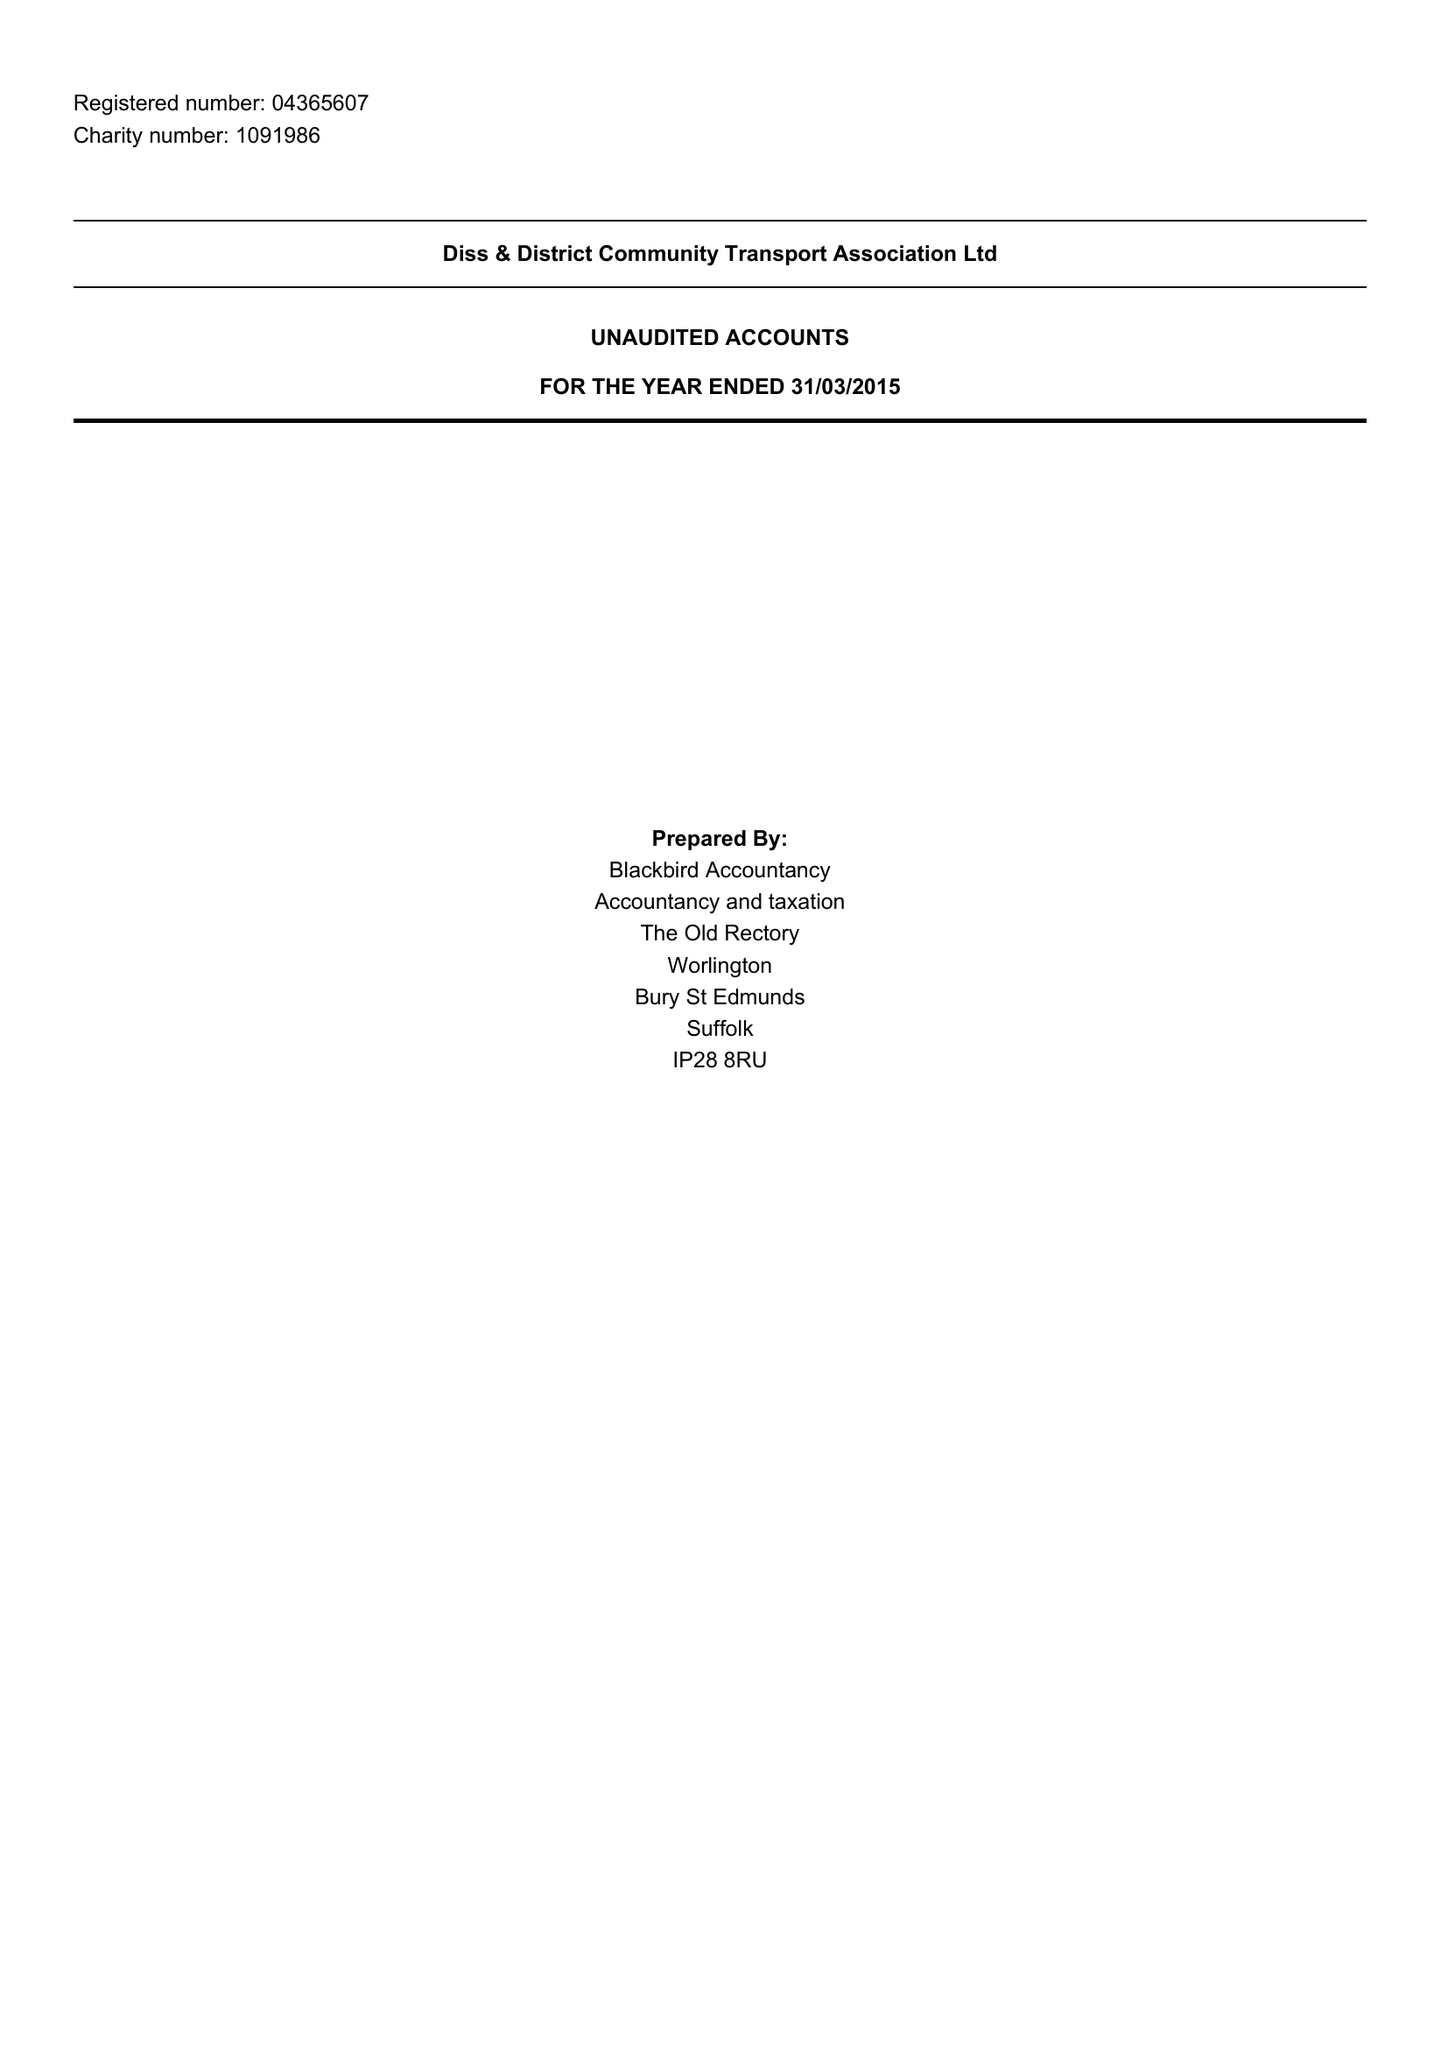What is the value for the charity_number?
Answer the question using a single word or phrase. 1091986 